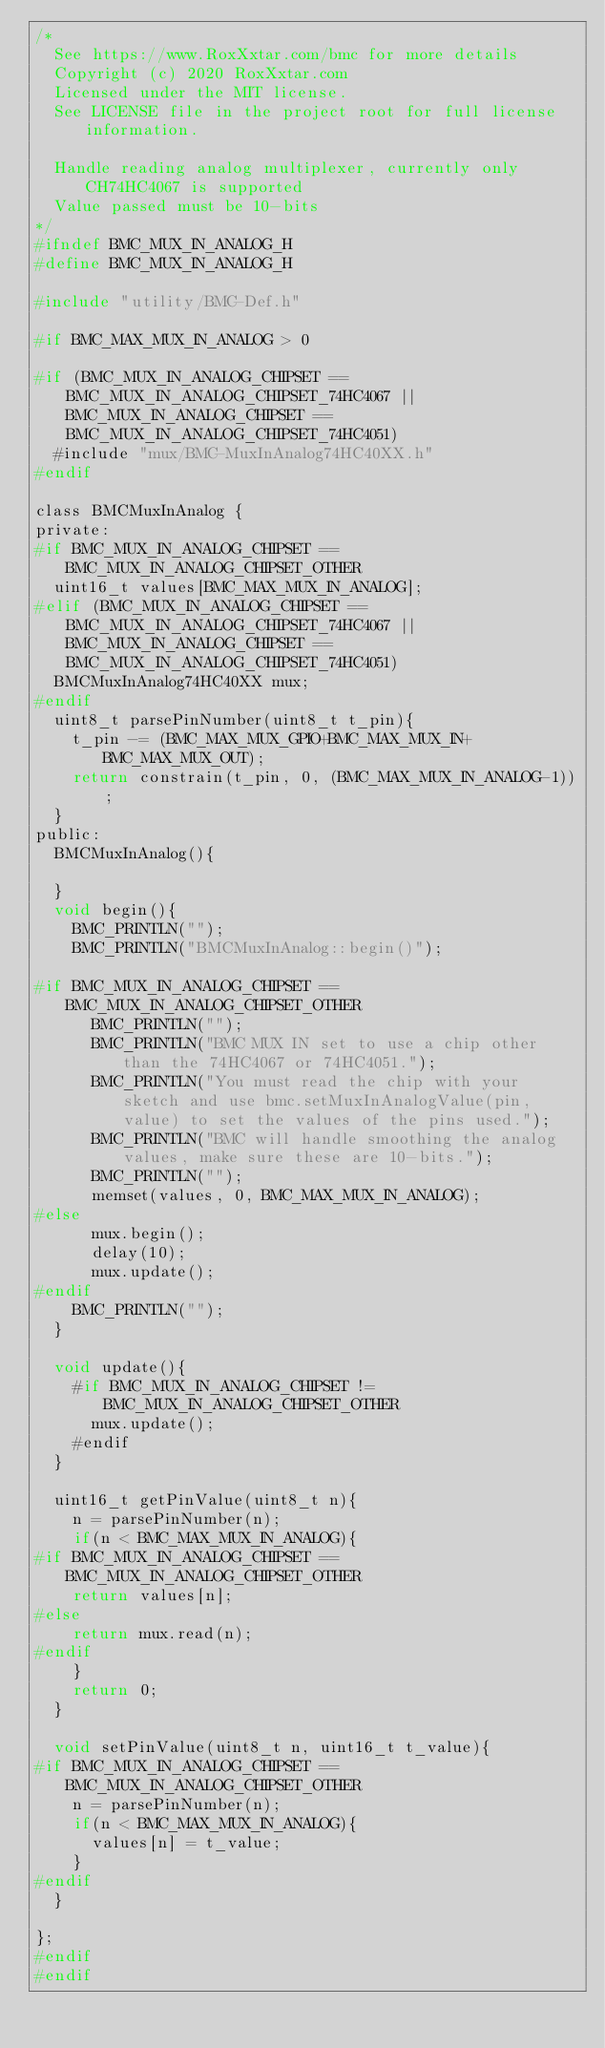<code> <loc_0><loc_0><loc_500><loc_500><_C_>/*
  See https://www.RoxXxtar.com/bmc for more details
  Copyright (c) 2020 RoxXxtar.com
  Licensed under the MIT license.
  See LICENSE file in the project root for full license information.

  Handle reading analog multiplexer, currently only CH74HC4067 is supported
  Value passed must be 10-bits
*/
#ifndef BMC_MUX_IN_ANALOG_H
#define BMC_MUX_IN_ANALOG_H

#include "utility/BMC-Def.h"

#if BMC_MAX_MUX_IN_ANALOG > 0

#if (BMC_MUX_IN_ANALOG_CHIPSET == BMC_MUX_IN_ANALOG_CHIPSET_74HC4067 || BMC_MUX_IN_ANALOG_CHIPSET == BMC_MUX_IN_ANALOG_CHIPSET_74HC4051)
  #include "mux/BMC-MuxInAnalog74HC40XX.h"
#endif

class BMCMuxInAnalog {
private:
#if BMC_MUX_IN_ANALOG_CHIPSET == BMC_MUX_IN_ANALOG_CHIPSET_OTHER
  uint16_t values[BMC_MAX_MUX_IN_ANALOG];
#elif (BMC_MUX_IN_ANALOG_CHIPSET == BMC_MUX_IN_ANALOG_CHIPSET_74HC4067 || BMC_MUX_IN_ANALOG_CHIPSET == BMC_MUX_IN_ANALOG_CHIPSET_74HC4051)
  BMCMuxInAnalog74HC40XX mux;
#endif
  uint8_t parsePinNumber(uint8_t t_pin){
    t_pin -= (BMC_MAX_MUX_GPIO+BMC_MAX_MUX_IN+BMC_MAX_MUX_OUT);
    return constrain(t_pin, 0, (BMC_MAX_MUX_IN_ANALOG-1));
  }
public:
  BMCMuxInAnalog(){

  }
  void begin(){
    BMC_PRINTLN("");
    BMC_PRINTLN("BMCMuxInAnalog::begin()");

#if BMC_MUX_IN_ANALOG_CHIPSET == BMC_MUX_IN_ANALOG_CHIPSET_OTHER
      BMC_PRINTLN("");
      BMC_PRINTLN("BMC MUX IN set to use a chip other than the 74HC4067 or 74HC4051.");
      BMC_PRINTLN("You must read the chip with your sketch and use bmc.setMuxInAnalogValue(pin, value) to set the values of the pins used.");
      BMC_PRINTLN("BMC will handle smoothing the analog values, make sure these are 10-bits.");
      BMC_PRINTLN("");
      memset(values, 0, BMC_MAX_MUX_IN_ANALOG);
#else
      mux.begin();
      delay(10);
      mux.update();
#endif
    BMC_PRINTLN("");
  }

  void update(){
    #if BMC_MUX_IN_ANALOG_CHIPSET != BMC_MUX_IN_ANALOG_CHIPSET_OTHER
      mux.update();
    #endif
  }

  uint16_t getPinValue(uint8_t n){
    n = parsePinNumber(n);
    if(n < BMC_MAX_MUX_IN_ANALOG){
#if BMC_MUX_IN_ANALOG_CHIPSET == BMC_MUX_IN_ANALOG_CHIPSET_OTHER
    return values[n];
#else
    return mux.read(n);
#endif
    }
    return 0;
  }

  void setPinValue(uint8_t n, uint16_t t_value){
#if BMC_MUX_IN_ANALOG_CHIPSET == BMC_MUX_IN_ANALOG_CHIPSET_OTHER
    n = parsePinNumber(n);
    if(n < BMC_MAX_MUX_IN_ANALOG){
      values[n] = t_value;
    }
#endif
  }

};
#endif
#endif
</code> 